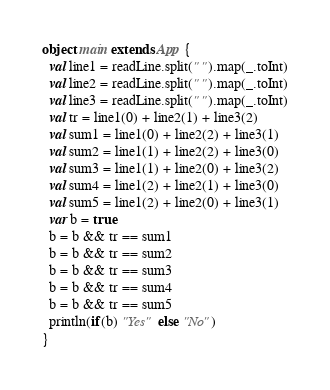<code> <loc_0><loc_0><loc_500><loc_500><_Scala_>object main extends App {
  val line1 = readLine.split(" ").map(_.toInt)
  val line2 = readLine.split(" ").map(_.toInt)
  val line3 = readLine.split(" ").map(_.toInt)
  val tr = line1(0) + line2(1) + line3(2)
  val sum1 = line1(0) + line2(2) + line3(1)
  val sum2 = line1(1) + line2(2) + line3(0)
  val sum3 = line1(1) + line2(0) + line3(2)
  val sum4 = line1(2) + line2(1) + line3(0)
  val sum5 = line1(2) + line2(0) + line3(1)
  var b = true
  b = b && tr == sum1
  b = b && tr == sum2
  b = b && tr == sum3
  b = b && tr == sum4
  b = b && tr == sum5
  println(if(b) "Yes" else "No")
}
</code> 